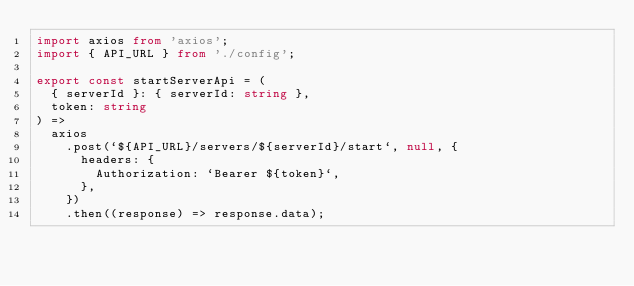Convert code to text. <code><loc_0><loc_0><loc_500><loc_500><_TypeScript_>import axios from 'axios';
import { API_URL } from './config';

export const startServerApi = (
  { serverId }: { serverId: string },
  token: string
) =>
  axios
    .post(`${API_URL}/servers/${serverId}/start`, null, {
      headers: {
        Authorization: `Bearer ${token}`,
      },
    })
    .then((response) => response.data);
</code> 